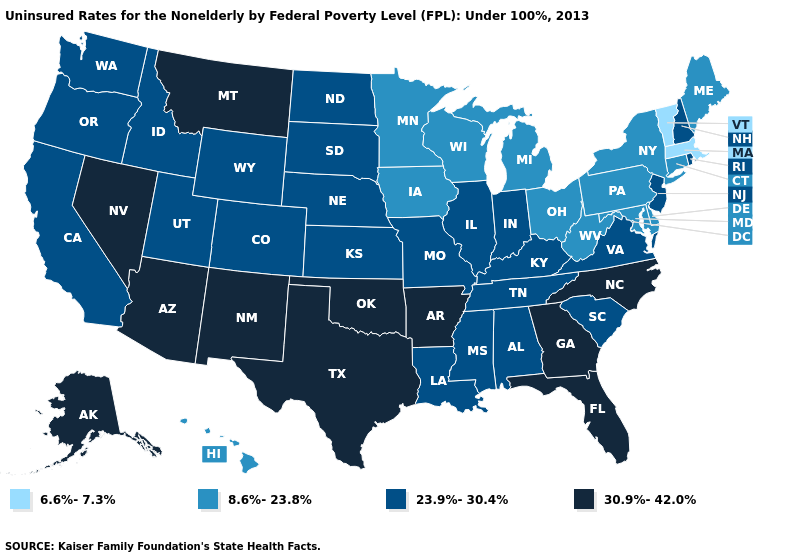What is the highest value in states that border Massachusetts?
Give a very brief answer. 23.9%-30.4%. Which states have the lowest value in the West?
Answer briefly. Hawaii. Name the states that have a value in the range 30.9%-42.0%?
Give a very brief answer. Alaska, Arizona, Arkansas, Florida, Georgia, Montana, Nevada, New Mexico, North Carolina, Oklahoma, Texas. Which states have the lowest value in the Northeast?
Write a very short answer. Massachusetts, Vermont. What is the highest value in states that border Michigan?
Keep it brief. 23.9%-30.4%. Which states have the lowest value in the MidWest?
Give a very brief answer. Iowa, Michigan, Minnesota, Ohio, Wisconsin. What is the value of New Hampshire?
Write a very short answer. 23.9%-30.4%. Name the states that have a value in the range 30.9%-42.0%?
Quick response, please. Alaska, Arizona, Arkansas, Florida, Georgia, Montana, Nevada, New Mexico, North Carolina, Oklahoma, Texas. What is the highest value in the West ?
Answer briefly. 30.9%-42.0%. Which states hav the highest value in the Northeast?
Give a very brief answer. New Hampshire, New Jersey, Rhode Island. Which states hav the highest value in the South?
Be succinct. Arkansas, Florida, Georgia, North Carolina, Oklahoma, Texas. What is the value of Colorado?
Answer briefly. 23.9%-30.4%. Name the states that have a value in the range 30.9%-42.0%?
Concise answer only. Alaska, Arizona, Arkansas, Florida, Georgia, Montana, Nevada, New Mexico, North Carolina, Oklahoma, Texas. Does Oklahoma have the lowest value in the USA?
Be succinct. No. Does Connecticut have the lowest value in the Northeast?
Write a very short answer. No. 